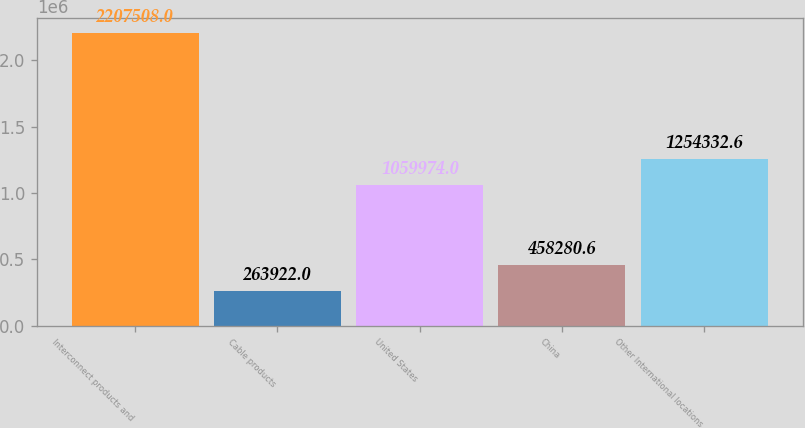<chart> <loc_0><loc_0><loc_500><loc_500><bar_chart><fcel>Interconnect products and<fcel>Cable products<fcel>United States<fcel>China<fcel>Other International locations<nl><fcel>2.20751e+06<fcel>263922<fcel>1.05997e+06<fcel>458281<fcel>1.25433e+06<nl></chart> 